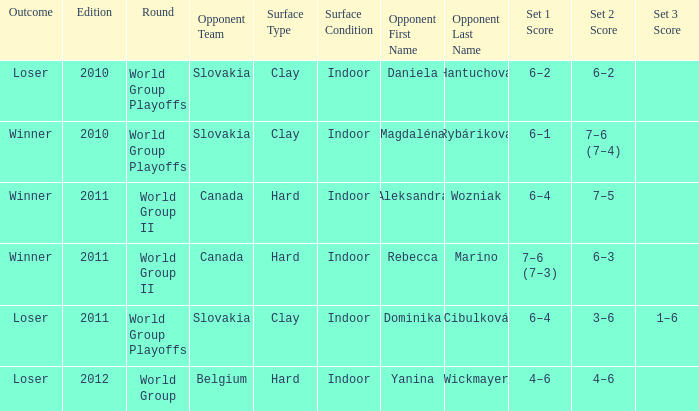How many results occurred when facing aleksandra wozniak as the opponent? 1.0. 